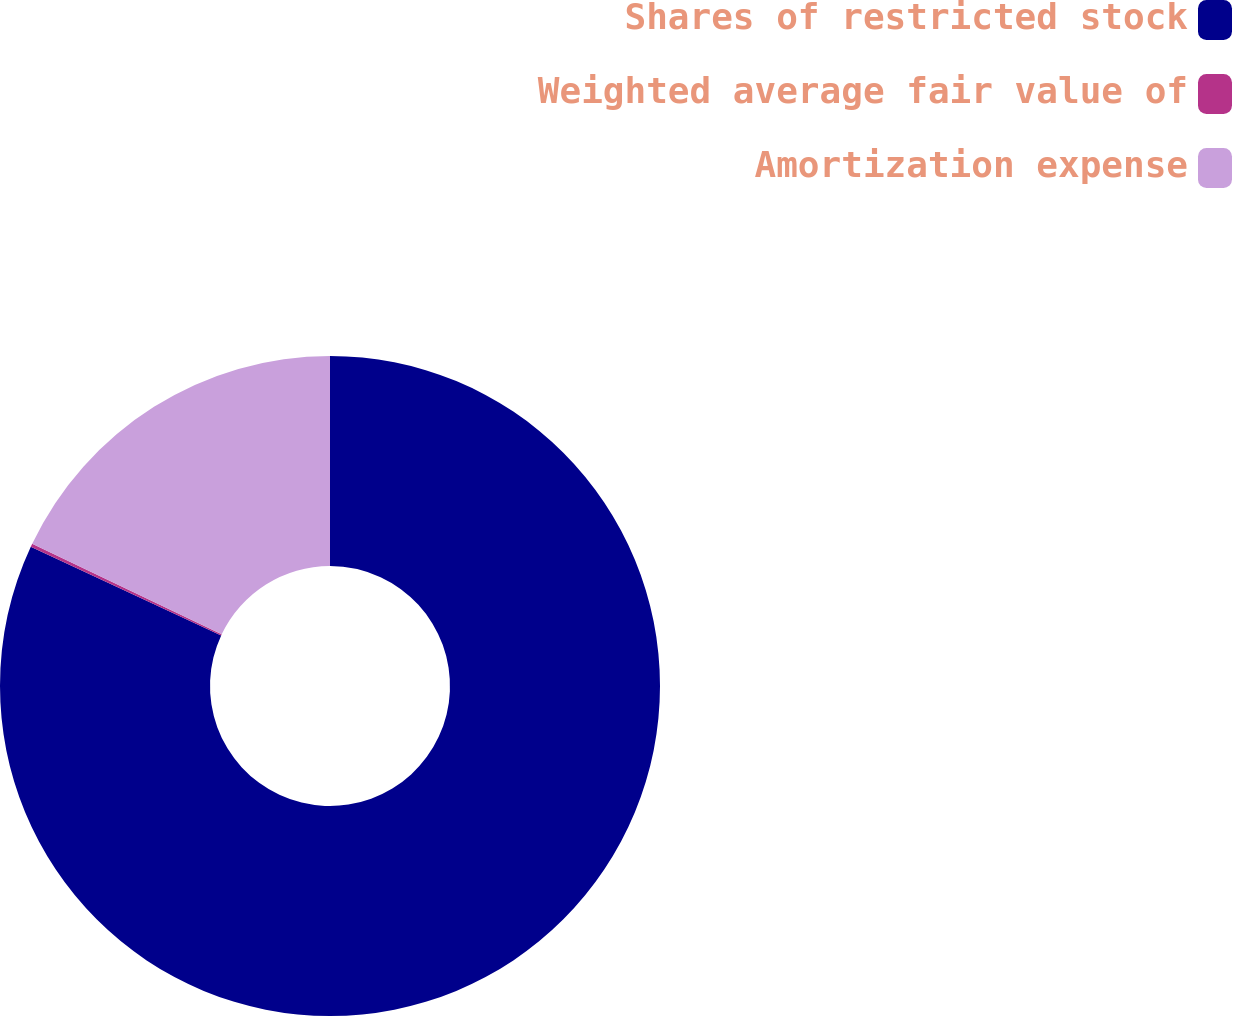Convert chart. <chart><loc_0><loc_0><loc_500><loc_500><pie_chart><fcel>Shares of restricted stock<fcel>Weighted average fair value of<fcel>Amortization expense<nl><fcel>81.93%<fcel>0.16%<fcel>17.91%<nl></chart> 